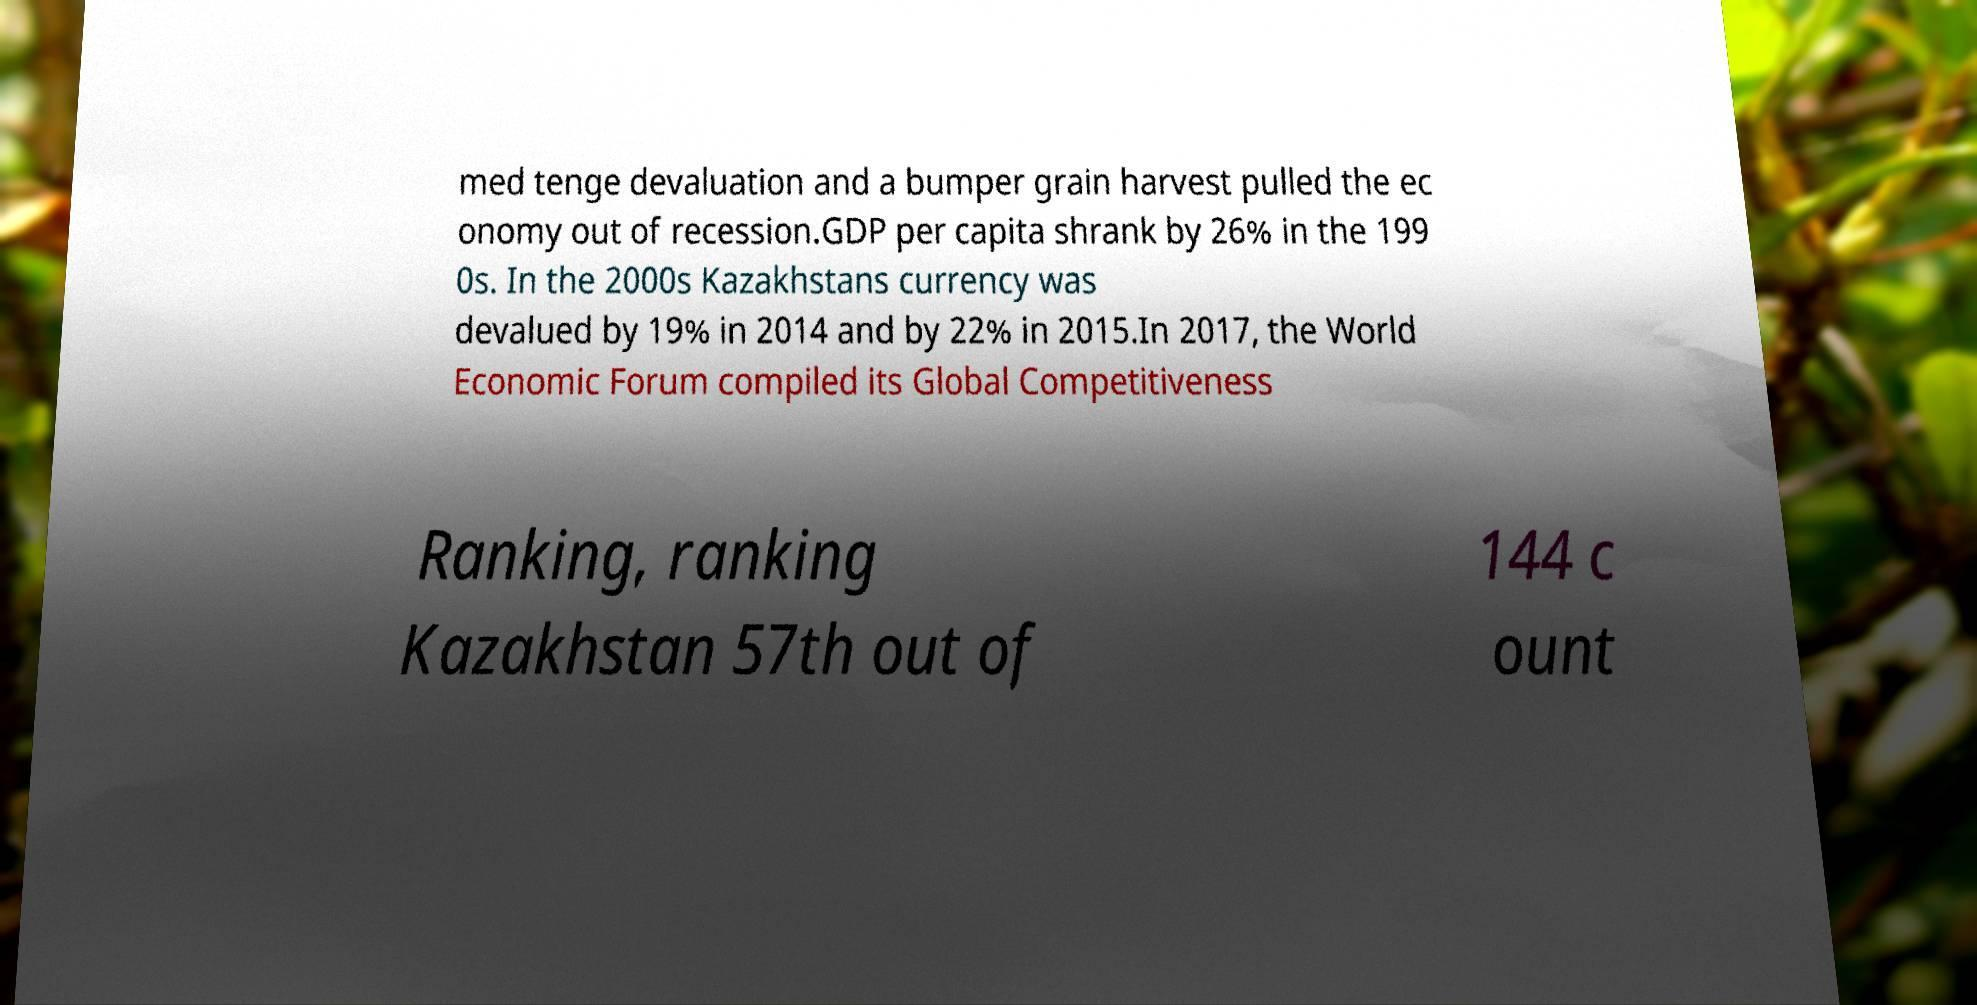Could you assist in decoding the text presented in this image and type it out clearly? med tenge devaluation and a bumper grain harvest pulled the ec onomy out of recession.GDP per capita shrank by 26% in the 199 0s. In the 2000s Kazakhstans currency was devalued by 19% in 2014 and by 22% in 2015.In 2017, the World Economic Forum compiled its Global Competitiveness Ranking, ranking Kazakhstan 57th out of 144 c ount 